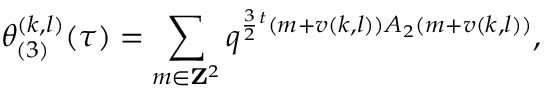Convert formula to latex. <formula><loc_0><loc_0><loc_500><loc_500>\theta _ { ( 3 ) } ^ { ( k , l ) } ( \tau ) = \sum _ { m \in { Z } ^ { 2 } } q ^ { \frac { 3 } { 2 ^ { t } ( m + v ( k , l ) ) A _ { 2 } ( m + v ( k , l ) ) } ,</formula> 